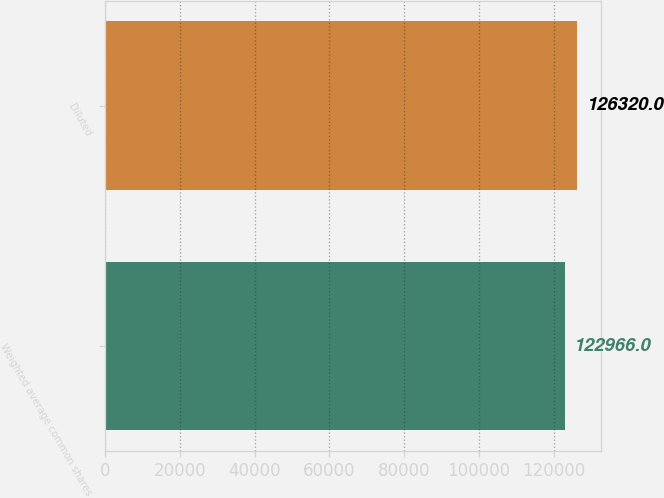<chart> <loc_0><loc_0><loc_500><loc_500><bar_chart><fcel>Weighted average common shares<fcel>Diluted<nl><fcel>122966<fcel>126320<nl></chart> 